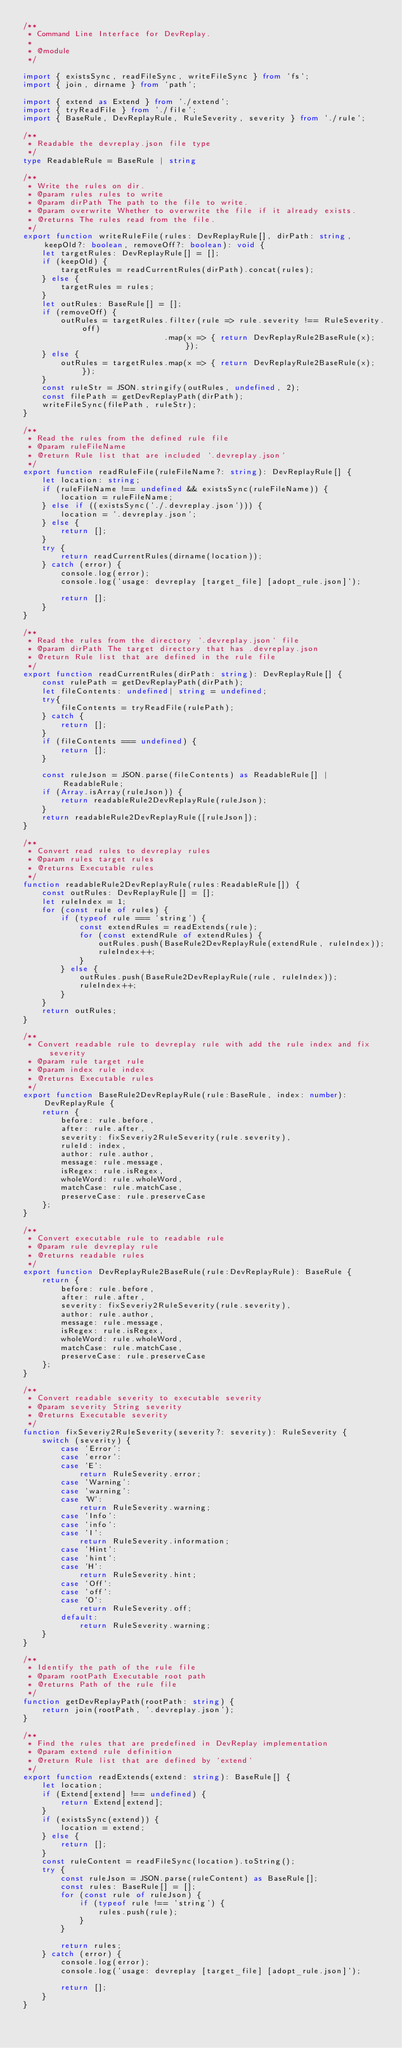Convert code to text. <code><loc_0><loc_0><loc_500><loc_500><_TypeScript_>/**
 * Command Line Interface for DevReplay.
 * 
 * @module
 */

import { existsSync, readFileSync, writeFileSync } from 'fs';
import { join, dirname } from 'path';

import { extend as Extend } from './extend';
import { tryReadFile } from './file';
import { BaseRule, DevReplayRule, RuleSeverity, severity } from './rule';

/**
 * Readable the devreplay.json file type
 */
type ReadableRule = BaseRule | string

/**
 * Write the rules on dir.
 * @param rules rules to write
 * @param dirPath The path to the file to write.
 * @param overwrite Whether to overwrite the file if it already exists.
 * @returns The rules read from the file.
 */
export function writeRuleFile(rules: DevReplayRule[], dirPath: string, keepOld?: boolean, removeOff?: boolean): void {
    let targetRules: DevReplayRule[] = [];
    if (keepOld) {
        targetRules = readCurrentRules(dirPath).concat(rules);
    } else {
        targetRules = rules;
    }
    let outRules: BaseRule[] = [];
    if (removeOff) {
        outRules = targetRules.filter(rule => rule.severity !== RuleSeverity.off)
                              .map(x => { return DevReplayRule2BaseRule(x); });
    } else {
        outRules = targetRules.map(x => { return DevReplayRule2BaseRule(x); });
    }
    const ruleStr = JSON.stringify(outRules, undefined, 2);
    const filePath = getDevReplayPath(dirPath);
    writeFileSync(filePath, ruleStr);
}

/**
 * Read the rules from the defined rule file
 * @param ruleFileName 
 * @return Rule list that are included `.devreplay.json`
 */
export function readRuleFile(ruleFileName?: string): DevReplayRule[] {
    let location: string;
    if (ruleFileName !== undefined && existsSync(ruleFileName)) {
        location = ruleFileName;
    } else if ((existsSync('./.devreplay.json'))) {
        location = '.devreplay.json';
    } else {
        return [];
    }
    try {
        return readCurrentRules(dirname(location));
    } catch (error) {
        console.log(error);
        console.log('usage: devreplay [target_file] [adopt_rule.json]');

        return [];
    }
}

/**
 * Read the rules from the directory `.devreplay.json` file
 * @param dirPath The target directory that has .devreplay.json
 * @return Rule list that are defined in the rule file
 */
export function readCurrentRules(dirPath: string): DevReplayRule[] {
    const rulePath = getDevReplayPath(dirPath);
    let fileContents: undefined| string = undefined;
    try{
        fileContents = tryReadFile(rulePath);
    } catch {
        return [];
    }
    if (fileContents === undefined) {
        return [];
    }

    const ruleJson = JSON.parse(fileContents) as ReadableRule[] | ReadableRule;
    if (Array.isArray(ruleJson)) {
        return readableRule2DevReplayRule(ruleJson);
    }
    return readableRule2DevReplayRule([ruleJson]);
}

/**
 * Convert read rules to devreplay rules
 * @param rules target rules
 * @returns Executable rules
 */
function readableRule2DevReplayRule(rules:ReadableRule[]) {
    const outRules: DevReplayRule[] = [];
    let ruleIndex = 1;
    for (const rule of rules) {
        if (typeof rule === 'string') {
            const extendRules = readExtends(rule);
            for (const extendRule of extendRules) {
                outRules.push(BaseRule2DevReplayRule(extendRule, ruleIndex));
                ruleIndex++;
            }
        } else {
            outRules.push(BaseRule2DevReplayRule(rule, ruleIndex));
            ruleIndex++;
        }
    }
    return outRules;
}

/**
 * Convert readable rule to devreplay rule with add the rule index and fix severity
 * @param rule target rule
 * @param index rule index
 * @returns Executable rules
 */
export function BaseRule2DevReplayRule(rule:BaseRule, index: number): DevReplayRule {
    return {
        before: rule.before,
        after: rule.after,
        severity: fixSeveriy2RuleSeverity(rule.severity),
        ruleId: index,
        author: rule.author,
        message: rule.message,
        isRegex: rule.isRegex,
        wholeWord: rule.wholeWord,
        matchCase: rule.matchCase,
        preserveCase: rule.preserveCase
    };
}

/**
 * Convert executable rule to readable rule
 * @param rule devreplay rule
 * @returns readable rules
 */
export function DevReplayRule2BaseRule(rule:DevReplayRule): BaseRule {
    return {
        before: rule.before,
        after: rule.after,
        severity: fixSeveriy2RuleSeverity(rule.severity),
        author: rule.author,
        message: rule.message,
        isRegex: rule.isRegex,
        wholeWord: rule.wholeWord,
        matchCase: rule.matchCase,
        preserveCase: rule.preserveCase
    };
}

/**
 * Convert readable severity to executable severity
 * @param severity String severity
 * @returns Executable severity
 */
function fixSeveriy2RuleSeverity(severity?: severity): RuleSeverity {
    switch (severity) {
        case 'Error':
        case 'error':
        case 'E':
            return RuleSeverity.error;
        case 'Warning':
        case 'warning':
        case 'W':
            return RuleSeverity.warning;
        case 'Info':
        case 'info':
        case 'I':
            return RuleSeverity.information;
        case 'Hint':
        case 'hint':
        case 'H':
            return RuleSeverity.hint;
        case 'Off':
        case 'off':
        case 'O':
            return RuleSeverity.off;
        default:
            return RuleSeverity.warning;
    }
}

/**
 * Identify the path of the rule file
 * @param rootPath Executable root path
 * @returns Path of the rule file
 */
function getDevReplayPath(rootPath: string) {
	return join(rootPath, '.devreplay.json');
}

/**
 * Find the rules that are predefined in DevReplay implementation
 * @param extend rule definition
 * @return Rule list that are defined by `extend`
 */
export function readExtends(extend: string): BaseRule[] {
    let location;
    if (Extend[extend] !== undefined) {
        return Extend[extend];
    }
    if (existsSync(extend)) {
        location = extend;
    } else {
        return [];
    }
    const ruleContent = readFileSync(location).toString();
    try {
        const ruleJson = JSON.parse(ruleContent) as BaseRule[];
        const rules: BaseRule[] = [];
        for (const rule of ruleJson) {
            if (typeof rule !== 'string') {
                rules.push(rule);
            }
        }

        return rules;
    } catch (error) {
        console.log(error);
        console.log('usage: devreplay [target_file] [adopt_rule.json]');

        return [];
    }
}
</code> 